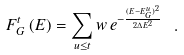<formula> <loc_0><loc_0><loc_500><loc_500>F ^ { t } _ { G } \left ( E \right ) = \sum _ { u \leq t } w \, e ^ { - \frac { ( E - E ^ { u } _ { G } ) ^ { 2 } } { 2 \Delta E ^ { 2 } } } \ .</formula> 